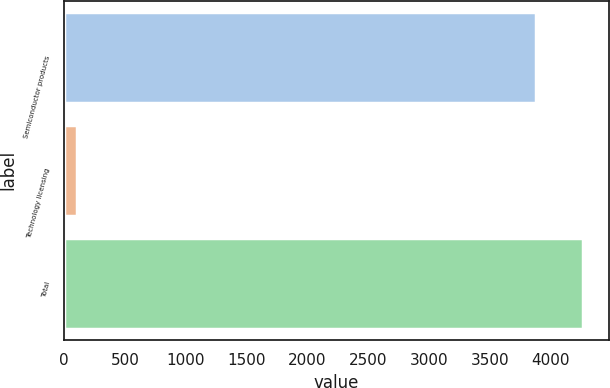Convert chart to OTSL. <chart><loc_0><loc_0><loc_500><loc_500><bar_chart><fcel>Semiconductor products<fcel>Technology licensing<fcel>Total<nl><fcel>3876<fcel>104.8<fcel>4263.6<nl></chart> 